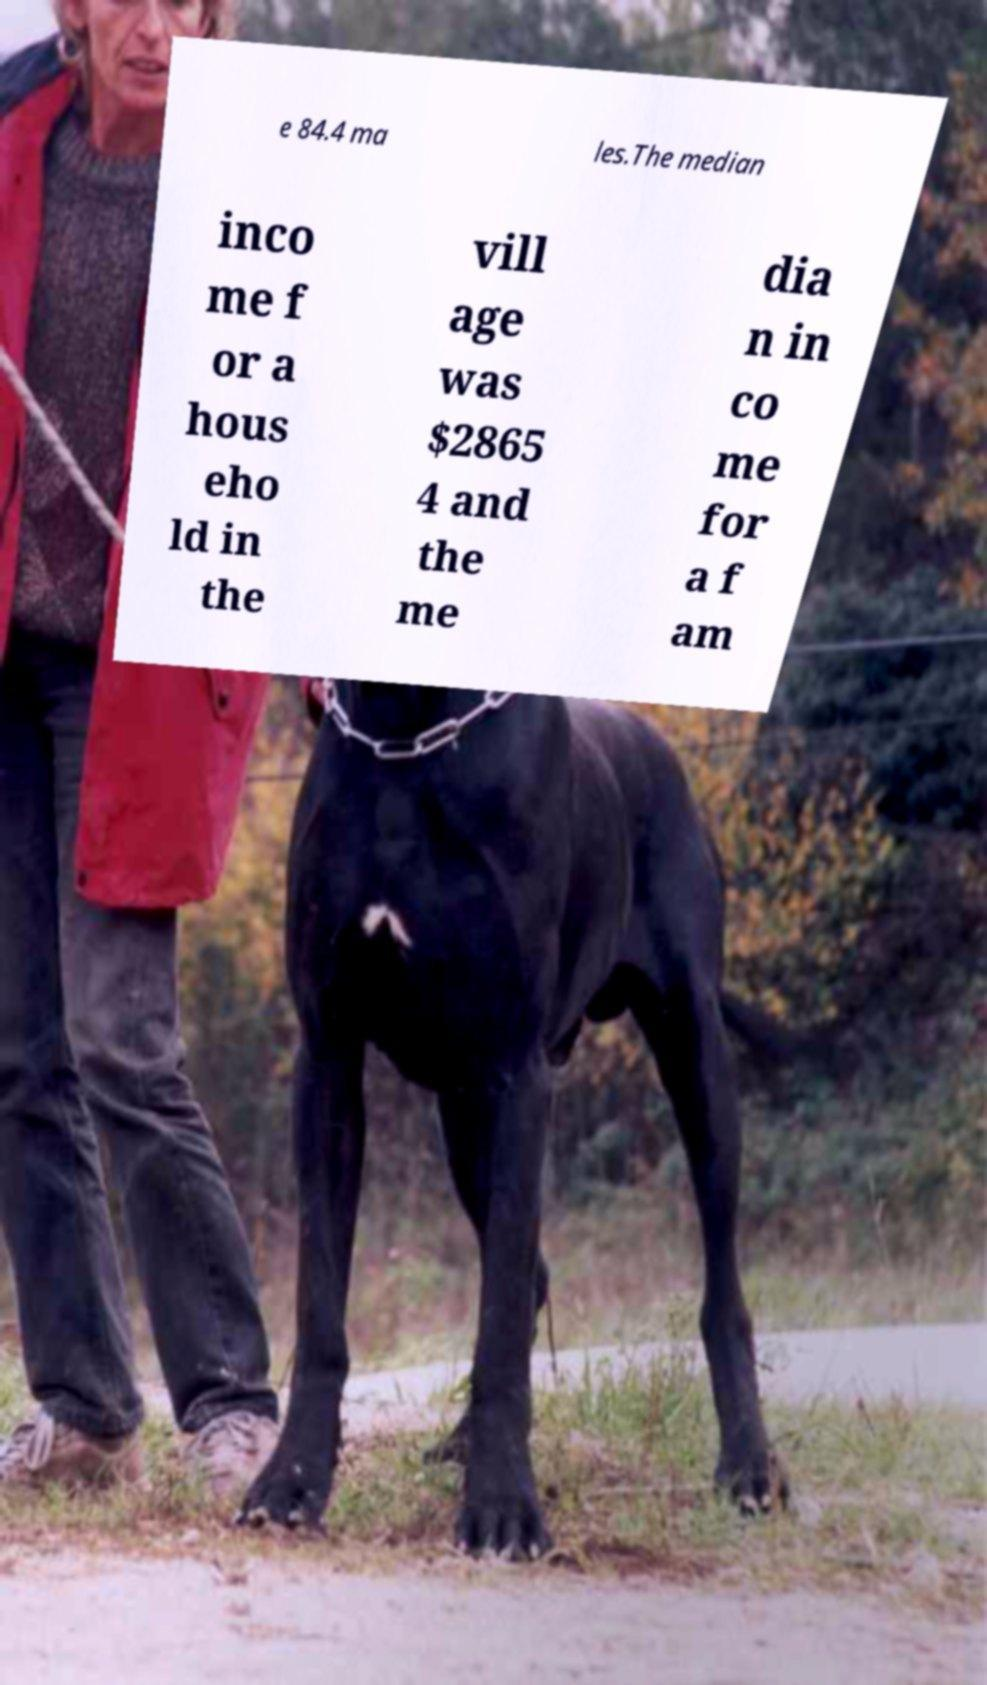Please identify and transcribe the text found in this image. e 84.4 ma les.The median inco me f or a hous eho ld in the vill age was $2865 4 and the me dia n in co me for a f am 